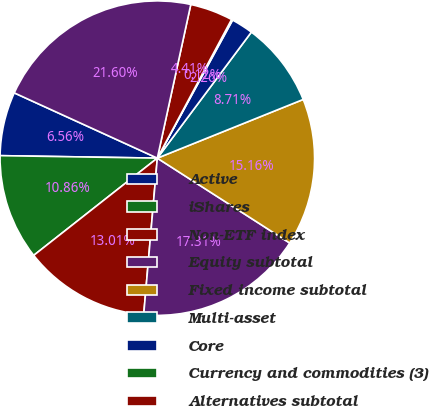Convert chart. <chart><loc_0><loc_0><loc_500><loc_500><pie_chart><fcel>Active<fcel>iShares<fcel>Non-ETF index<fcel>Equity subtotal<fcel>Fixed income subtotal<fcel>Multi-asset<fcel>Core<fcel>Currency and commodities (3)<fcel>Alternatives subtotal<fcel>Long-term<nl><fcel>6.56%<fcel>10.86%<fcel>13.01%<fcel>17.31%<fcel>15.16%<fcel>8.71%<fcel>2.26%<fcel>0.12%<fcel>4.41%<fcel>21.6%<nl></chart> 